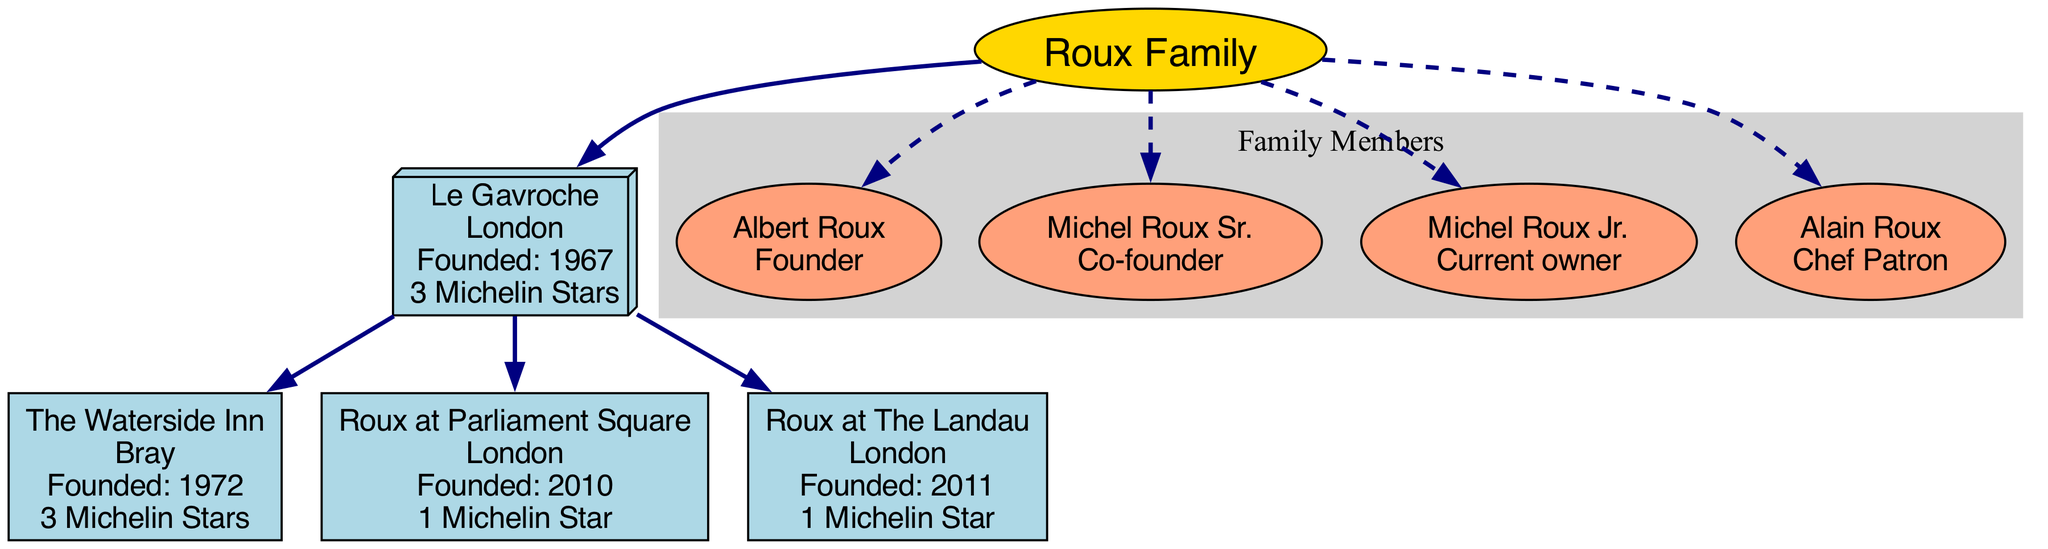What is the name of the root restaurant? The diagram identifies "Le Gavroche" as the root restaurant connected directly to the family node.
Answer: Le Gavroche How many Michelin stars does "The Waterside Inn" have? By examining the branch labeled "The Waterside Inn", it is noted that it has 3 Michelin stars.
Answer: 3 Which family member is the current owner? The current owner is directly indicated in the family members section, identifying "Michel Roux Jr." as the titleholder.
Answer: Michel Roux Jr In which year was "Roux at The Landau" founded? Looking under the branch for "Roux at The Landau", it shows that this restaurant was founded in the year 2011.
Answer: 2011 How many restaurants are connected to the root restaurant? Counting the branches emanating from the root restaurant "Le Gavroche", there are three unique branches identified.
Answer: 3 Which restaurant is located in Bray? Among the branches listed, "The Waterside Inn" is specifically noted as being in Bray.
Answer: The Waterside Inn What role does Alain Roux hold? Referring to the family members section, Alain Roux is assigned the role of Chef Patron.
Answer: Chef Patron Which location has the youngest restaurant? By comparing the founding years of the branches, "Roux at Parliament Square" (2010) is identified as the most recently founded restaurant.
Answer: Roux at Parliament Square How many Michelin stars does the root restaurant have? The diagram specifies that the root restaurant "Le Gavroche" boasts a total of 3 Michelin stars.
Answer: 3 